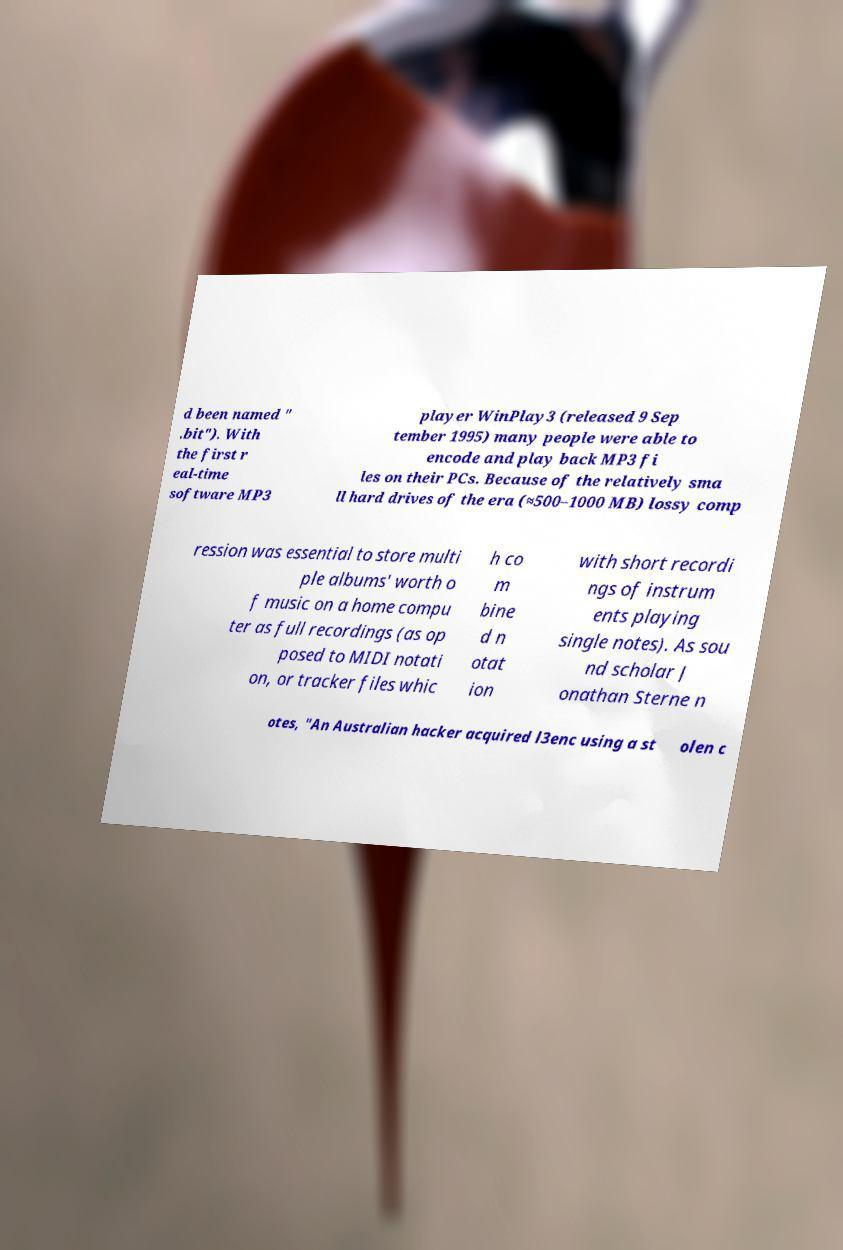For documentation purposes, I need the text within this image transcribed. Could you provide that? d been named " .bit"). With the first r eal-time software MP3 player WinPlay3 (released 9 Sep tember 1995) many people were able to encode and play back MP3 fi les on their PCs. Because of the relatively sma ll hard drives of the era (≈500–1000 MB) lossy comp ression was essential to store multi ple albums' worth o f music on a home compu ter as full recordings (as op posed to MIDI notati on, or tracker files whic h co m bine d n otat ion with short recordi ngs of instrum ents playing single notes). As sou nd scholar J onathan Sterne n otes, "An Australian hacker acquired l3enc using a st olen c 